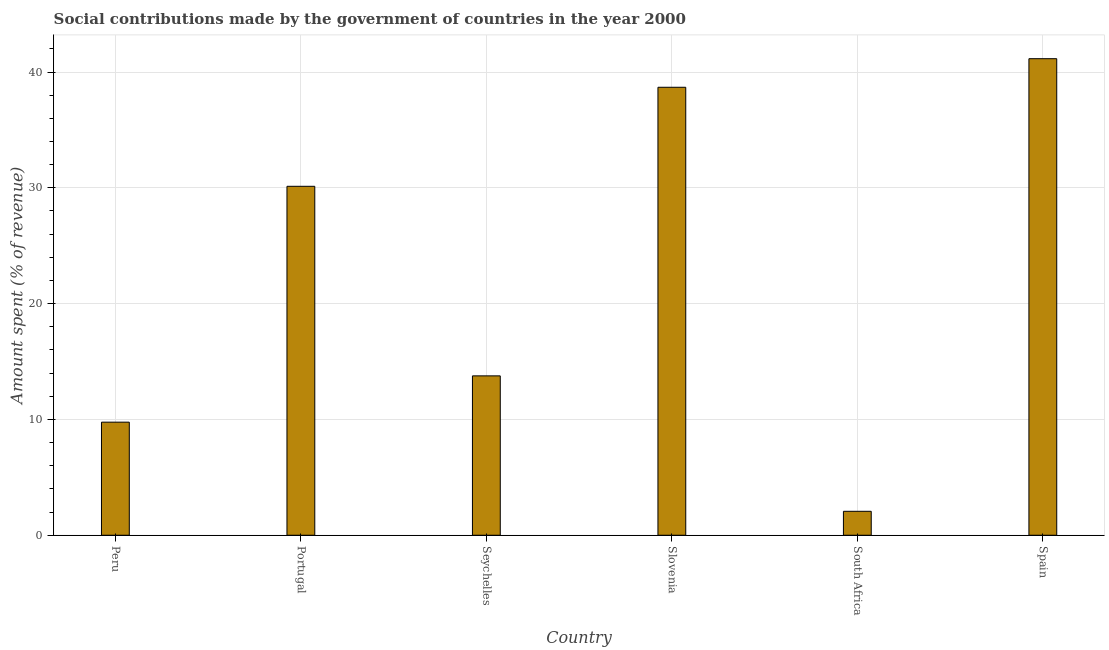What is the title of the graph?
Your response must be concise. Social contributions made by the government of countries in the year 2000. What is the label or title of the Y-axis?
Provide a short and direct response. Amount spent (% of revenue). What is the amount spent in making social contributions in Peru?
Your answer should be compact. 9.76. Across all countries, what is the maximum amount spent in making social contributions?
Provide a succinct answer. 41.15. Across all countries, what is the minimum amount spent in making social contributions?
Provide a succinct answer. 2.07. In which country was the amount spent in making social contributions maximum?
Offer a terse response. Spain. In which country was the amount spent in making social contributions minimum?
Your answer should be very brief. South Africa. What is the sum of the amount spent in making social contributions?
Ensure brevity in your answer.  135.55. What is the difference between the amount spent in making social contributions in Seychelles and Slovenia?
Your response must be concise. -24.92. What is the average amount spent in making social contributions per country?
Your answer should be compact. 22.59. What is the median amount spent in making social contributions?
Provide a succinct answer. 21.95. What is the ratio of the amount spent in making social contributions in Peru to that in Slovenia?
Make the answer very short. 0.25. Is the difference between the amount spent in making social contributions in Peru and South Africa greater than the difference between any two countries?
Offer a terse response. No. What is the difference between the highest and the second highest amount spent in making social contributions?
Make the answer very short. 2.47. Is the sum of the amount spent in making social contributions in Seychelles and South Africa greater than the maximum amount spent in making social contributions across all countries?
Make the answer very short. No. What is the difference between the highest and the lowest amount spent in making social contributions?
Provide a succinct answer. 39.08. In how many countries, is the amount spent in making social contributions greater than the average amount spent in making social contributions taken over all countries?
Keep it short and to the point. 3. How many bars are there?
Your response must be concise. 6. Are all the bars in the graph horizontal?
Keep it short and to the point. No. What is the difference between two consecutive major ticks on the Y-axis?
Give a very brief answer. 10. What is the Amount spent (% of revenue) in Peru?
Offer a terse response. 9.76. What is the Amount spent (% of revenue) in Portugal?
Provide a short and direct response. 30.13. What is the Amount spent (% of revenue) of Seychelles?
Offer a terse response. 13.76. What is the Amount spent (% of revenue) in Slovenia?
Provide a succinct answer. 38.68. What is the Amount spent (% of revenue) of South Africa?
Provide a succinct answer. 2.07. What is the Amount spent (% of revenue) in Spain?
Provide a short and direct response. 41.15. What is the difference between the Amount spent (% of revenue) in Peru and Portugal?
Provide a short and direct response. -20.37. What is the difference between the Amount spent (% of revenue) in Peru and Seychelles?
Offer a very short reply. -4. What is the difference between the Amount spent (% of revenue) in Peru and Slovenia?
Make the answer very short. -28.92. What is the difference between the Amount spent (% of revenue) in Peru and South Africa?
Make the answer very short. 7.7. What is the difference between the Amount spent (% of revenue) in Peru and Spain?
Your answer should be very brief. -31.39. What is the difference between the Amount spent (% of revenue) in Portugal and Seychelles?
Offer a terse response. 16.37. What is the difference between the Amount spent (% of revenue) in Portugal and Slovenia?
Provide a succinct answer. -8.55. What is the difference between the Amount spent (% of revenue) in Portugal and South Africa?
Offer a terse response. 28.06. What is the difference between the Amount spent (% of revenue) in Portugal and Spain?
Offer a very short reply. -11.02. What is the difference between the Amount spent (% of revenue) in Seychelles and Slovenia?
Give a very brief answer. -24.92. What is the difference between the Amount spent (% of revenue) in Seychelles and South Africa?
Your answer should be compact. 11.69. What is the difference between the Amount spent (% of revenue) in Seychelles and Spain?
Offer a terse response. -27.39. What is the difference between the Amount spent (% of revenue) in Slovenia and South Africa?
Provide a short and direct response. 36.62. What is the difference between the Amount spent (% of revenue) in Slovenia and Spain?
Offer a terse response. -2.47. What is the difference between the Amount spent (% of revenue) in South Africa and Spain?
Offer a very short reply. -39.08. What is the ratio of the Amount spent (% of revenue) in Peru to that in Portugal?
Your answer should be very brief. 0.32. What is the ratio of the Amount spent (% of revenue) in Peru to that in Seychelles?
Provide a succinct answer. 0.71. What is the ratio of the Amount spent (% of revenue) in Peru to that in Slovenia?
Ensure brevity in your answer.  0.25. What is the ratio of the Amount spent (% of revenue) in Peru to that in South Africa?
Offer a very short reply. 4.72. What is the ratio of the Amount spent (% of revenue) in Peru to that in Spain?
Ensure brevity in your answer.  0.24. What is the ratio of the Amount spent (% of revenue) in Portugal to that in Seychelles?
Ensure brevity in your answer.  2.19. What is the ratio of the Amount spent (% of revenue) in Portugal to that in Slovenia?
Make the answer very short. 0.78. What is the ratio of the Amount spent (% of revenue) in Portugal to that in South Africa?
Provide a succinct answer. 14.58. What is the ratio of the Amount spent (% of revenue) in Portugal to that in Spain?
Provide a succinct answer. 0.73. What is the ratio of the Amount spent (% of revenue) in Seychelles to that in Slovenia?
Keep it short and to the point. 0.36. What is the ratio of the Amount spent (% of revenue) in Seychelles to that in South Africa?
Offer a terse response. 6.66. What is the ratio of the Amount spent (% of revenue) in Seychelles to that in Spain?
Provide a short and direct response. 0.33. What is the ratio of the Amount spent (% of revenue) in Slovenia to that in South Africa?
Your answer should be compact. 18.72. 